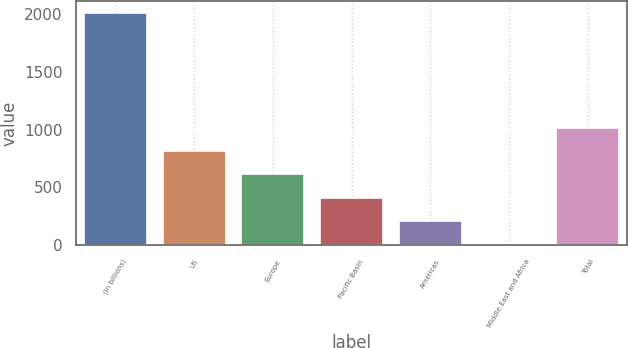Convert chart to OTSL. <chart><loc_0><loc_0><loc_500><loc_500><bar_chart><fcel>(In billions)<fcel>US<fcel>Europe<fcel>Pacific Basin<fcel>Americas<fcel>Middle East and Africa<fcel>Total<nl><fcel>2011<fcel>811.6<fcel>611.7<fcel>411.8<fcel>211.9<fcel>12<fcel>1011.5<nl></chart> 